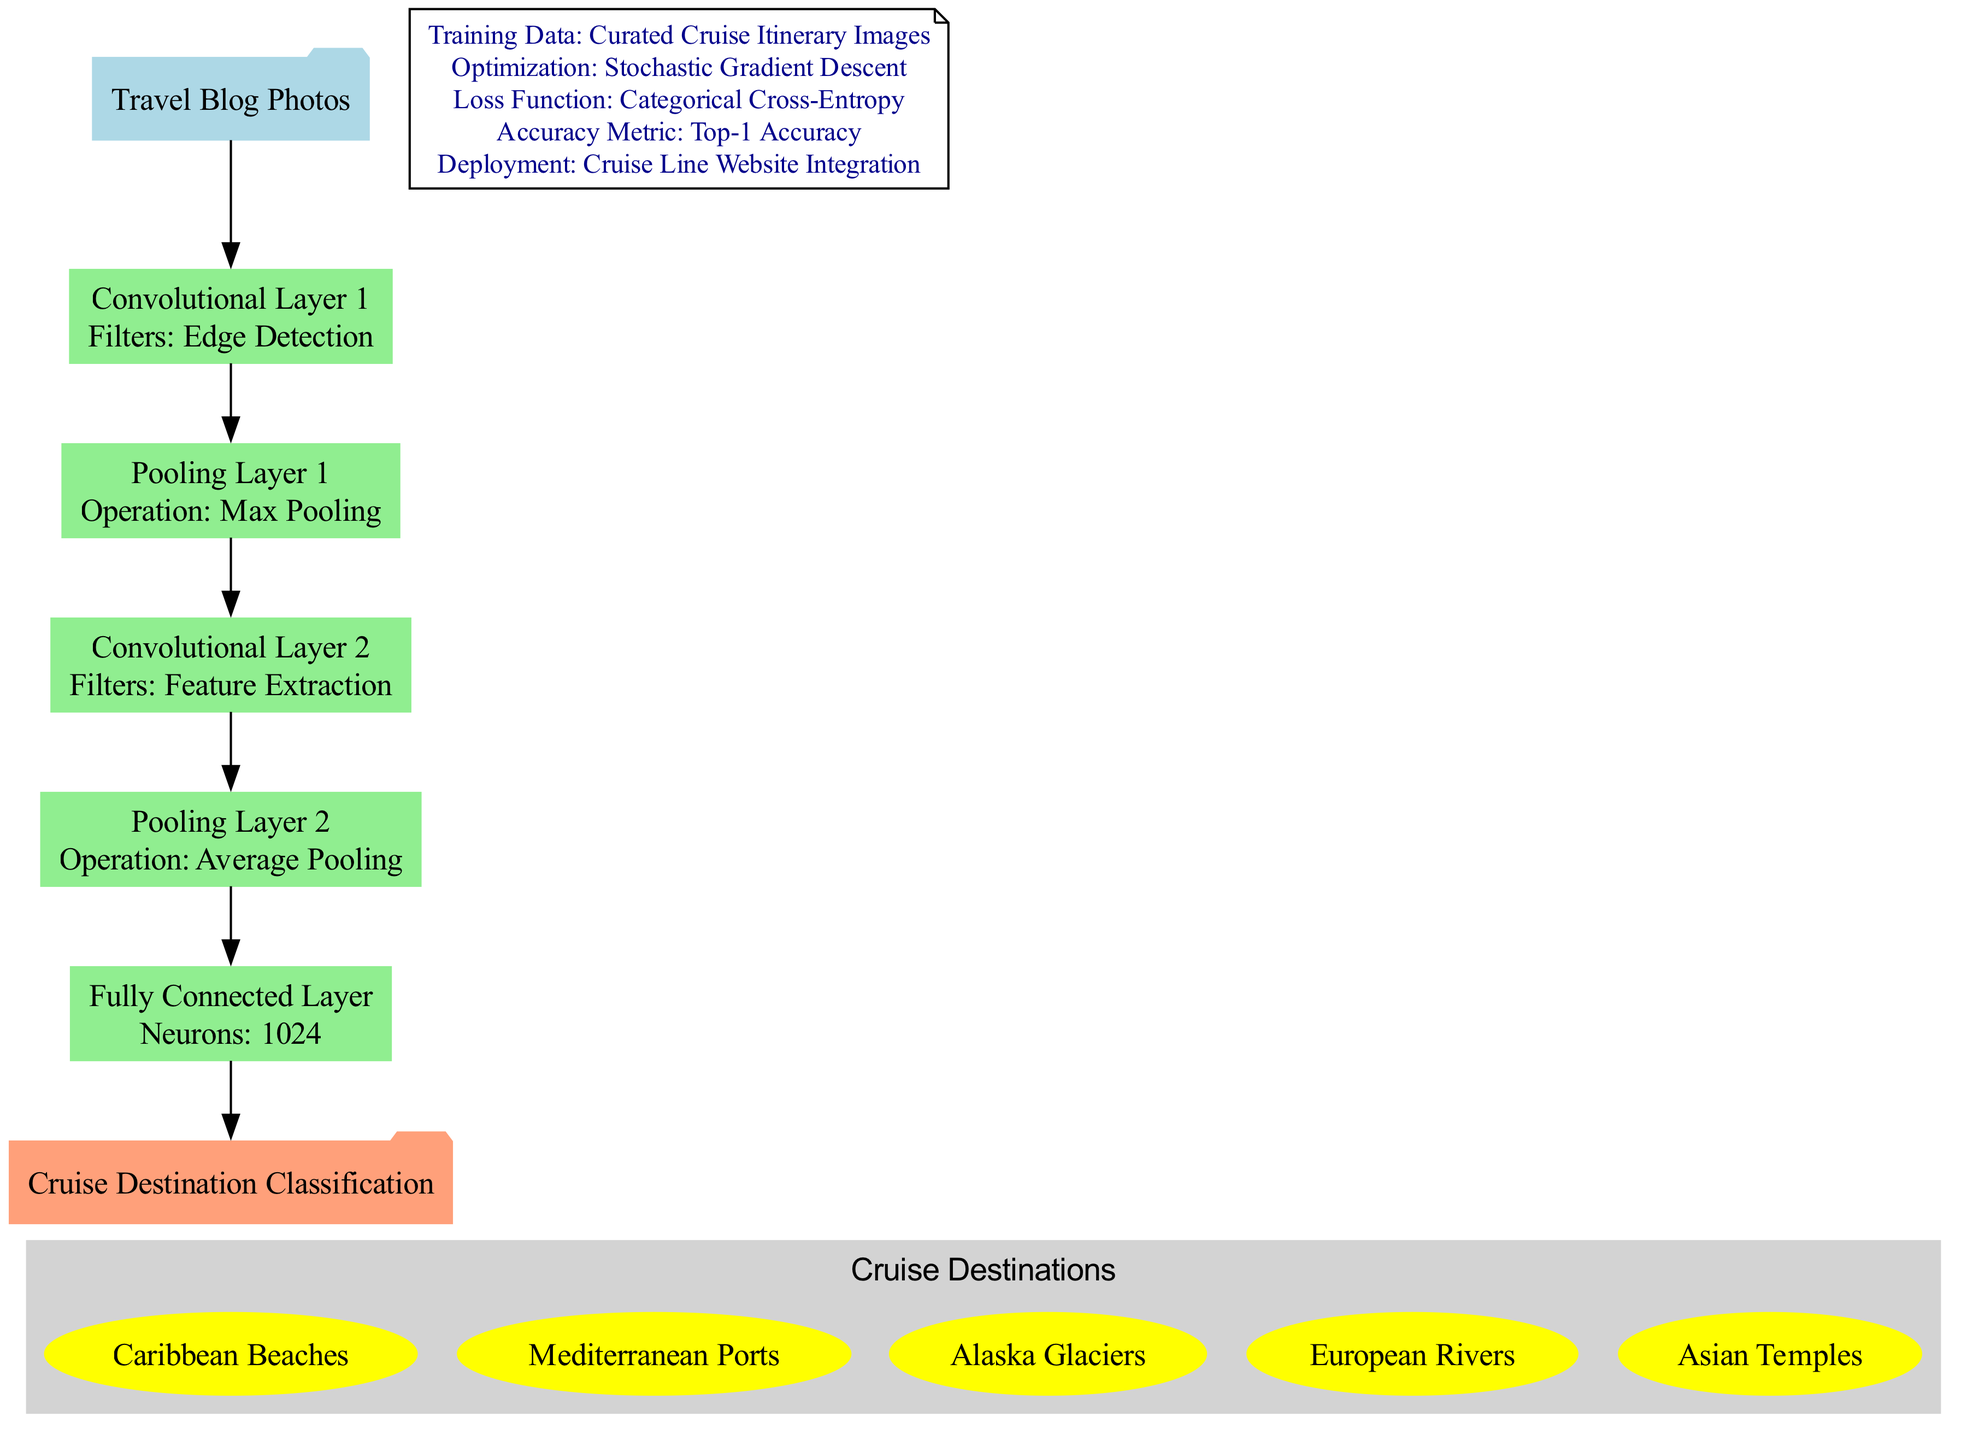what is the input to the model? The diagram indicates that the input to the model is "Travel Blog Photos." This is depicted at the top of the diagram in a folder shape labeled "Travel Blog Photos."
Answer: Travel Blog Photos how many layers are in the model? By examining the diagram, there are a total of five layers depicted, including two convolutional layers, two pooling layers, and one fully connected layer.
Answer: 5 what type of pooling operation is used in the first pooling layer? The first pooling layer in the diagram is labeled as using "Max Pooling." This information is directly shown in the layer's description box.
Answer: Max Pooling how many neurons are in the fully connected layer? The diagram specifies the fully connected layer has "1024 Neurons" as indicated in the description box of that layer.
Answer: 1024 what is the output classification of the model? The output classification of the model is listed as "Cruise Destination Classification," which is shown in the folder shape at the bottom of the diagram.
Answer: Cruise Destination Classification name one class of cruise destinations identified in the model. The diagram lists different classes of cruise destinations, one of which is "Caribbean Beaches," shown inside the cluster of cruise destination classes.
Answer: Caribbean Beaches what is the optimization technique used for training? According to the additional information node, the optimization technique used is "Stochastic Gradient Descent," which is one of the training parameters described.
Answer: Stochastic Gradient Descent what loss function is utilized in this model? The loss function utilized in this model, as specified in the additional information node, is "Categorical Cross-Entropy." This is described in the section detailing training specifications.
Answer: Categorical Cross-Entropy what metric is used to evaluate the model's performance? The metric used to evaluate the model's performance is "Top-1 Accuracy," as indicated in the additional information section of the diagram.
Answer: Top-1 Accuracy 